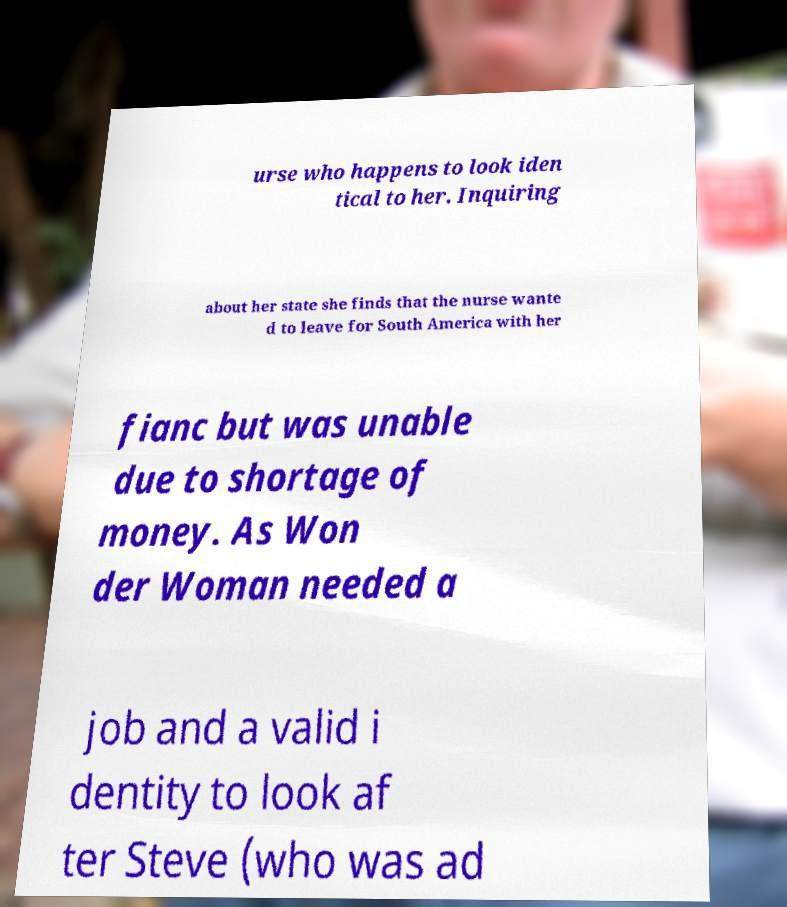Could you extract and type out the text from this image? urse who happens to look iden tical to her. Inquiring about her state she finds that the nurse wante d to leave for South America with her fianc but was unable due to shortage of money. As Won der Woman needed a job and a valid i dentity to look af ter Steve (who was ad 